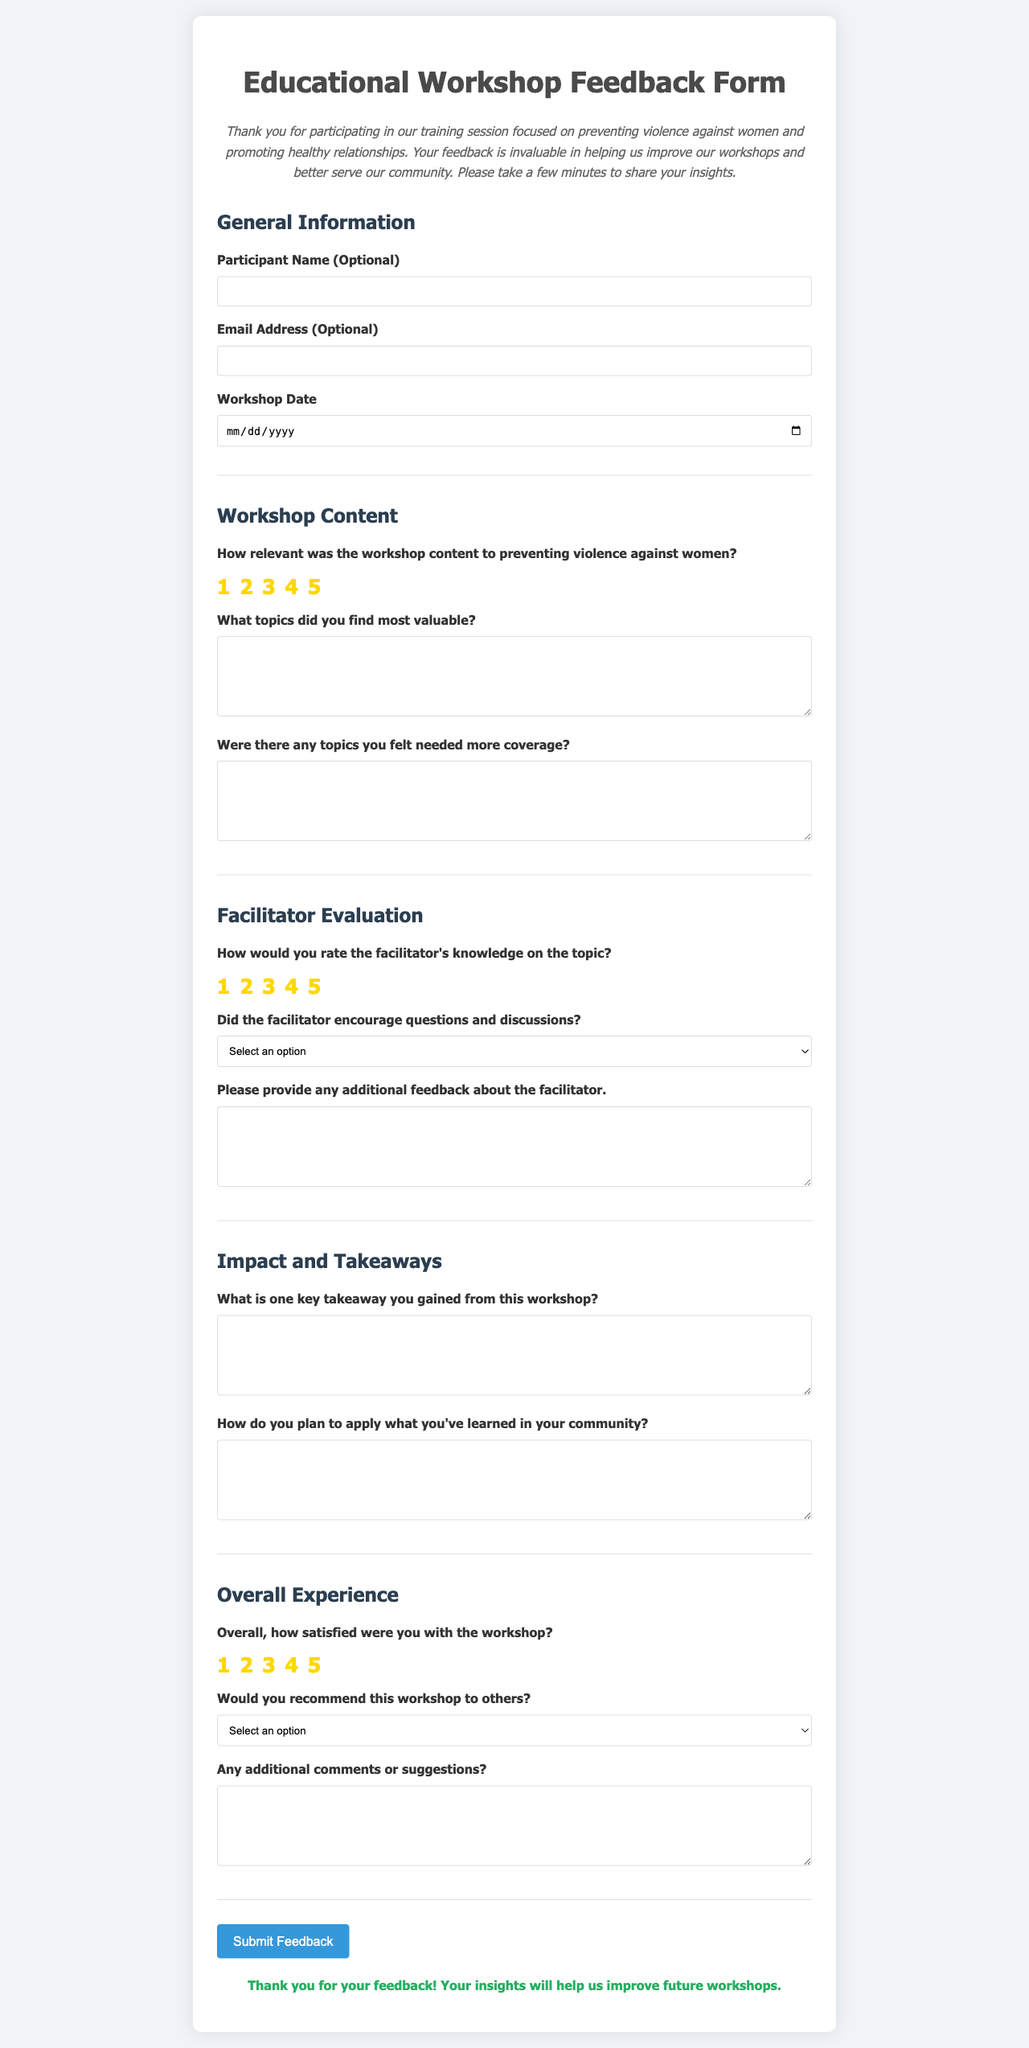What is the title of the document? The title is prominently displayed at the top of the document.
Answer: Educational Workshop Feedback Form What is the purpose of the form? The purpose is stated in the introduction section of the document.
Answer: Gather feedback What are the two optional fields in the General Information section? The optional fields are specifically mentioned in the General Information section.
Answer: Participant Name, Email Address How many rating stars are provided for evaluating relevance? The document mentions the number of stars available for rating relevance.
Answer: 5 What is one of the required questions regarding facilitator evaluation? The required questions are highlighted in the Facilitator Evaluation section.
Answer: How would you rate the facilitator's knowledge on the topic? What does the submission button say? The text on the button is important for understanding the action it performs.
Answer: Submit Feedback What is mentioned regarding additional comments or suggestions? This is noted in the Overall Experience section of the document.
Answer: Any additional comments or suggestions? What is the color of the submit button? The document describes the color of the button visually.
Answer: Blue Would you recommend this workshop to others? This question is a part of the Overall Experience section.
Answer: Yes/No (select option) 